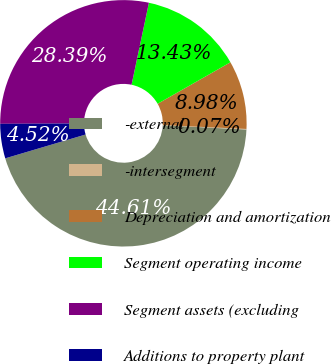Convert chart to OTSL. <chart><loc_0><loc_0><loc_500><loc_500><pie_chart><fcel>-external<fcel>-intersegment<fcel>Depreciation and amortization<fcel>Segment operating income<fcel>Segment assets (excluding<fcel>Additions to property plant<nl><fcel>44.61%<fcel>0.07%<fcel>8.98%<fcel>13.43%<fcel>28.39%<fcel>4.52%<nl></chart> 